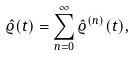Convert formula to latex. <formula><loc_0><loc_0><loc_500><loc_500>\hat { \varrho } ( t ) = \sum _ { n = 0 } ^ { \infty } \hat { \varrho } ^ { ( n ) } ( t ) ,</formula> 